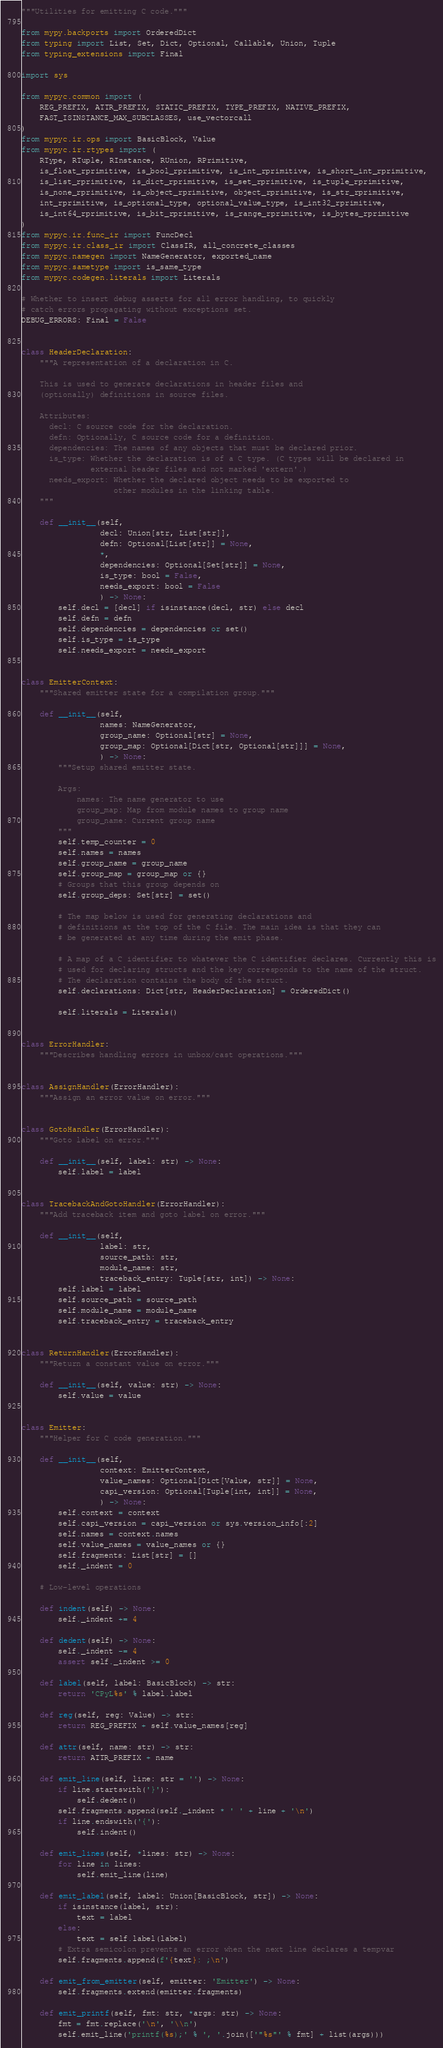Convert code to text. <code><loc_0><loc_0><loc_500><loc_500><_Python_>"""Utilities for emitting C code."""

from mypy.backports import OrderedDict
from typing import List, Set, Dict, Optional, Callable, Union, Tuple
from typing_extensions import Final

import sys

from mypyc.common import (
    REG_PREFIX, ATTR_PREFIX, STATIC_PREFIX, TYPE_PREFIX, NATIVE_PREFIX,
    FAST_ISINSTANCE_MAX_SUBCLASSES, use_vectorcall
)
from mypyc.ir.ops import BasicBlock, Value
from mypyc.ir.rtypes import (
    RType, RTuple, RInstance, RUnion, RPrimitive,
    is_float_rprimitive, is_bool_rprimitive, is_int_rprimitive, is_short_int_rprimitive,
    is_list_rprimitive, is_dict_rprimitive, is_set_rprimitive, is_tuple_rprimitive,
    is_none_rprimitive, is_object_rprimitive, object_rprimitive, is_str_rprimitive,
    int_rprimitive, is_optional_type, optional_value_type, is_int32_rprimitive,
    is_int64_rprimitive, is_bit_rprimitive, is_range_rprimitive, is_bytes_rprimitive
)
from mypyc.ir.func_ir import FuncDecl
from mypyc.ir.class_ir import ClassIR, all_concrete_classes
from mypyc.namegen import NameGenerator, exported_name
from mypyc.sametype import is_same_type
from mypyc.codegen.literals import Literals

# Whether to insert debug asserts for all error handling, to quickly
# catch errors propagating without exceptions set.
DEBUG_ERRORS: Final = False


class HeaderDeclaration:
    """A representation of a declaration in C.

    This is used to generate declarations in header files and
    (optionally) definitions in source files.

    Attributes:
      decl: C source code for the declaration.
      defn: Optionally, C source code for a definition.
      dependencies: The names of any objects that must be declared prior.
      is_type: Whether the declaration is of a C type. (C types will be declared in
               external header files and not marked 'extern'.)
      needs_export: Whether the declared object needs to be exported to
                    other modules in the linking table.
    """

    def __init__(self,
                 decl: Union[str, List[str]],
                 defn: Optional[List[str]] = None,
                 *,
                 dependencies: Optional[Set[str]] = None,
                 is_type: bool = False,
                 needs_export: bool = False
                 ) -> None:
        self.decl = [decl] if isinstance(decl, str) else decl
        self.defn = defn
        self.dependencies = dependencies or set()
        self.is_type = is_type
        self.needs_export = needs_export


class EmitterContext:
    """Shared emitter state for a compilation group."""

    def __init__(self,
                 names: NameGenerator,
                 group_name: Optional[str] = None,
                 group_map: Optional[Dict[str, Optional[str]]] = None,
                 ) -> None:
        """Setup shared emitter state.

        Args:
            names: The name generator to use
            group_map: Map from module names to group name
            group_name: Current group name
        """
        self.temp_counter = 0
        self.names = names
        self.group_name = group_name
        self.group_map = group_map or {}
        # Groups that this group depends on
        self.group_deps: Set[str] = set()

        # The map below is used for generating declarations and
        # definitions at the top of the C file. The main idea is that they can
        # be generated at any time during the emit phase.

        # A map of a C identifier to whatever the C identifier declares. Currently this is
        # used for declaring structs and the key corresponds to the name of the struct.
        # The declaration contains the body of the struct.
        self.declarations: Dict[str, HeaderDeclaration] = OrderedDict()

        self.literals = Literals()


class ErrorHandler:
    """Describes handling errors in unbox/cast operations."""


class AssignHandler(ErrorHandler):
    """Assign an error value on error."""


class GotoHandler(ErrorHandler):
    """Goto label on error."""

    def __init__(self, label: str) -> None:
        self.label = label


class TracebackAndGotoHandler(ErrorHandler):
    """Add traceback item and goto label on error."""

    def __init__(self,
                 label: str,
                 source_path: str,
                 module_name: str,
                 traceback_entry: Tuple[str, int]) -> None:
        self.label = label
        self.source_path = source_path
        self.module_name = module_name
        self.traceback_entry = traceback_entry


class ReturnHandler(ErrorHandler):
    """Return a constant value on error."""

    def __init__(self, value: str) -> None:
        self.value = value


class Emitter:
    """Helper for C code generation."""

    def __init__(self,
                 context: EmitterContext,
                 value_names: Optional[Dict[Value, str]] = None,
                 capi_version: Optional[Tuple[int, int]] = None,
                 ) -> None:
        self.context = context
        self.capi_version = capi_version or sys.version_info[:2]
        self.names = context.names
        self.value_names = value_names or {}
        self.fragments: List[str] = []
        self._indent = 0

    # Low-level operations

    def indent(self) -> None:
        self._indent += 4

    def dedent(self) -> None:
        self._indent -= 4
        assert self._indent >= 0

    def label(self, label: BasicBlock) -> str:
        return 'CPyL%s' % label.label

    def reg(self, reg: Value) -> str:
        return REG_PREFIX + self.value_names[reg]

    def attr(self, name: str) -> str:
        return ATTR_PREFIX + name

    def emit_line(self, line: str = '') -> None:
        if line.startswith('}'):
            self.dedent()
        self.fragments.append(self._indent * ' ' + line + '\n')
        if line.endswith('{'):
            self.indent()

    def emit_lines(self, *lines: str) -> None:
        for line in lines:
            self.emit_line(line)

    def emit_label(self, label: Union[BasicBlock, str]) -> None:
        if isinstance(label, str):
            text = label
        else:
            text = self.label(label)
        # Extra semicolon prevents an error when the next line declares a tempvar
        self.fragments.append(f'{text}: ;\n')

    def emit_from_emitter(self, emitter: 'Emitter') -> None:
        self.fragments.extend(emitter.fragments)

    def emit_printf(self, fmt: str, *args: str) -> None:
        fmt = fmt.replace('\n', '\\n')
        self.emit_line('printf(%s);' % ', '.join(['"%s"' % fmt] + list(args)))</code> 